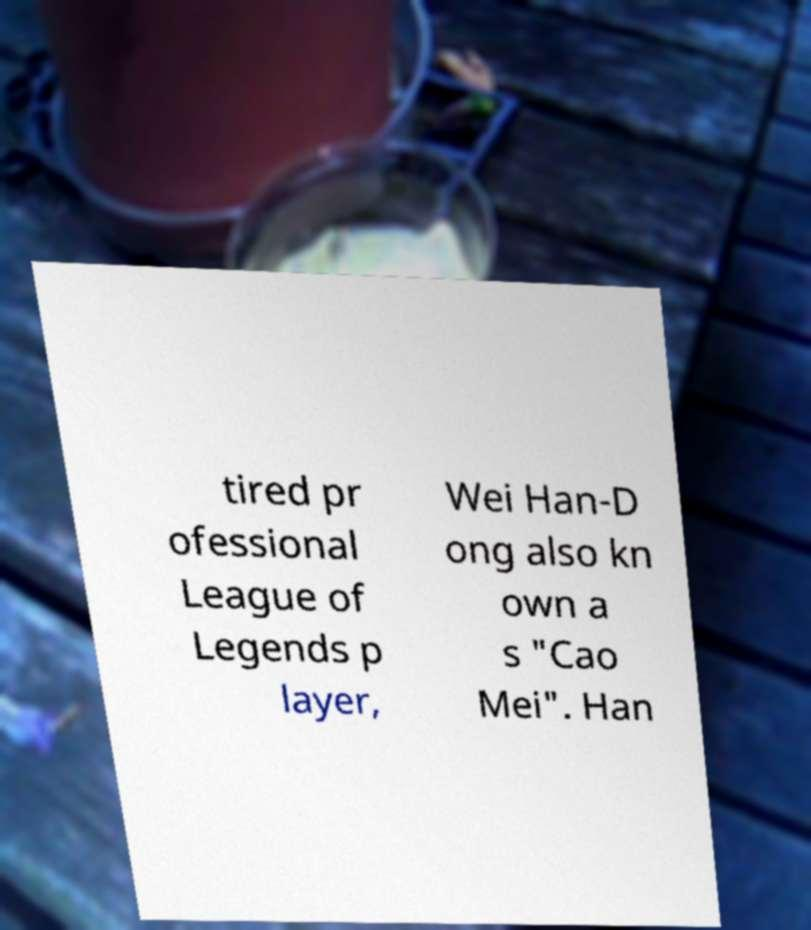What messages or text are displayed in this image? I need them in a readable, typed format. tired pr ofessional League of Legends p layer, Wei Han-D ong also kn own a s "Cao Mei". Han 